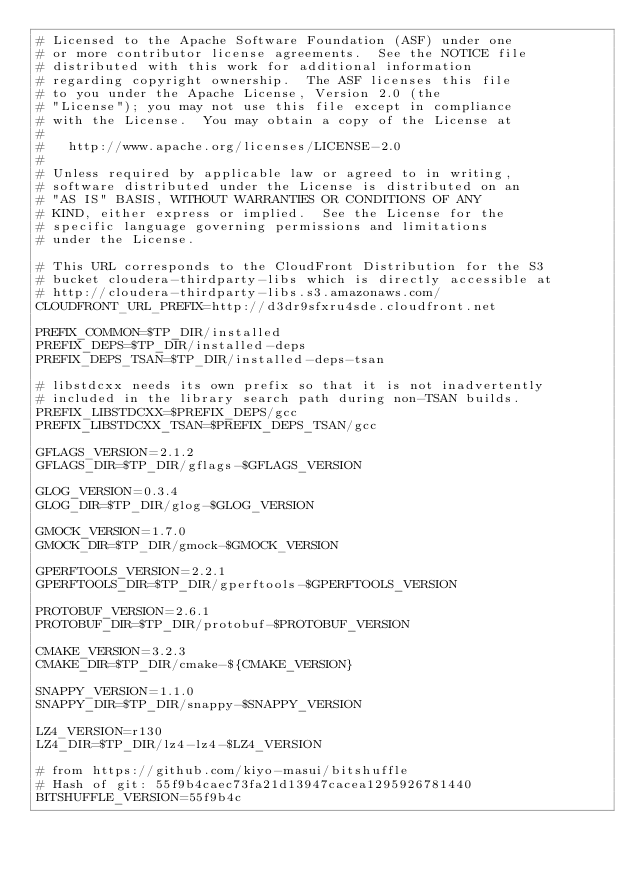<code> <loc_0><loc_0><loc_500><loc_500><_Bash_># Licensed to the Apache Software Foundation (ASF) under one
# or more contributor license agreements.  See the NOTICE file
# distributed with this work for additional information
# regarding copyright ownership.  The ASF licenses this file
# to you under the Apache License, Version 2.0 (the
# "License"); you may not use this file except in compliance
# with the License.  You may obtain a copy of the License at
#
#   http://www.apache.org/licenses/LICENSE-2.0
#
# Unless required by applicable law or agreed to in writing,
# software distributed under the License is distributed on an
# "AS IS" BASIS, WITHOUT WARRANTIES OR CONDITIONS OF ANY
# KIND, either express or implied.  See the License for the
# specific language governing permissions and limitations
# under the License.

# This URL corresponds to the CloudFront Distribution for the S3
# bucket cloudera-thirdparty-libs which is directly accessible at
# http://cloudera-thirdparty-libs.s3.amazonaws.com/
CLOUDFRONT_URL_PREFIX=http://d3dr9sfxru4sde.cloudfront.net

PREFIX_COMMON=$TP_DIR/installed
PREFIX_DEPS=$TP_DIR/installed-deps
PREFIX_DEPS_TSAN=$TP_DIR/installed-deps-tsan

# libstdcxx needs its own prefix so that it is not inadvertently
# included in the library search path during non-TSAN builds.
PREFIX_LIBSTDCXX=$PREFIX_DEPS/gcc
PREFIX_LIBSTDCXX_TSAN=$PREFIX_DEPS_TSAN/gcc

GFLAGS_VERSION=2.1.2
GFLAGS_DIR=$TP_DIR/gflags-$GFLAGS_VERSION

GLOG_VERSION=0.3.4
GLOG_DIR=$TP_DIR/glog-$GLOG_VERSION

GMOCK_VERSION=1.7.0
GMOCK_DIR=$TP_DIR/gmock-$GMOCK_VERSION

GPERFTOOLS_VERSION=2.2.1
GPERFTOOLS_DIR=$TP_DIR/gperftools-$GPERFTOOLS_VERSION

PROTOBUF_VERSION=2.6.1
PROTOBUF_DIR=$TP_DIR/protobuf-$PROTOBUF_VERSION

CMAKE_VERSION=3.2.3
CMAKE_DIR=$TP_DIR/cmake-${CMAKE_VERSION}

SNAPPY_VERSION=1.1.0
SNAPPY_DIR=$TP_DIR/snappy-$SNAPPY_VERSION

LZ4_VERSION=r130
LZ4_DIR=$TP_DIR/lz4-lz4-$LZ4_VERSION

# from https://github.com/kiyo-masui/bitshuffle
# Hash of git: 55f9b4caec73fa21d13947cacea1295926781440
BITSHUFFLE_VERSION=55f9b4c</code> 